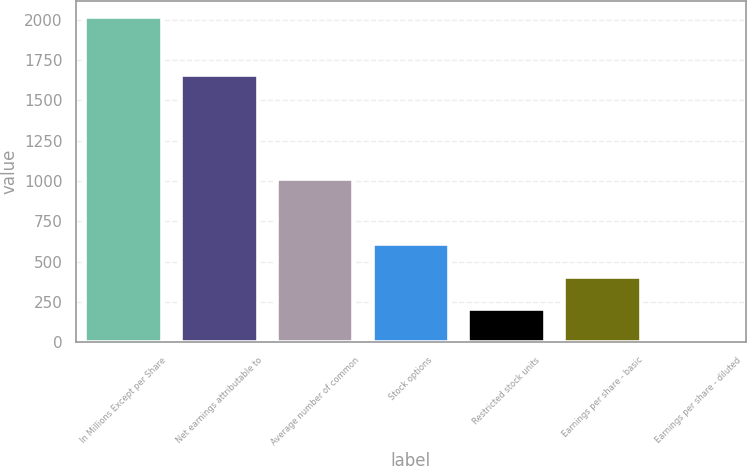<chart> <loc_0><loc_0><loc_500><loc_500><bar_chart><fcel>In Millions Except per Share<fcel>Net earnings attributable to<fcel>Average number of common<fcel>Stock options<fcel>Restricted stock units<fcel>Earnings per share - basic<fcel>Earnings per share - diluted<nl><fcel>2017<fcel>1657.5<fcel>1009.87<fcel>607.03<fcel>204.19<fcel>405.61<fcel>2.77<nl></chart> 